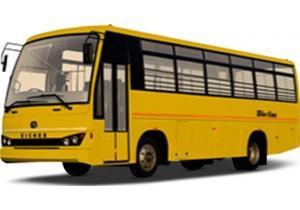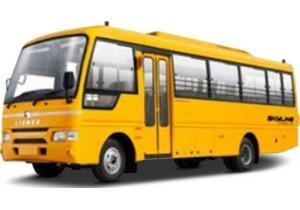The first image is the image on the left, the second image is the image on the right. Given the left and right images, does the statement "The buses in the left and right images face leftward, and neither bus has a driver behind the wheel." hold true? Answer yes or no. Yes. The first image is the image on the left, the second image is the image on the right. For the images displayed, is the sentence "Two school buses are angled in the same direction, one with side double doors behind the front tire, and the other with double doors in front of the tire." factually correct? Answer yes or no. Yes. 